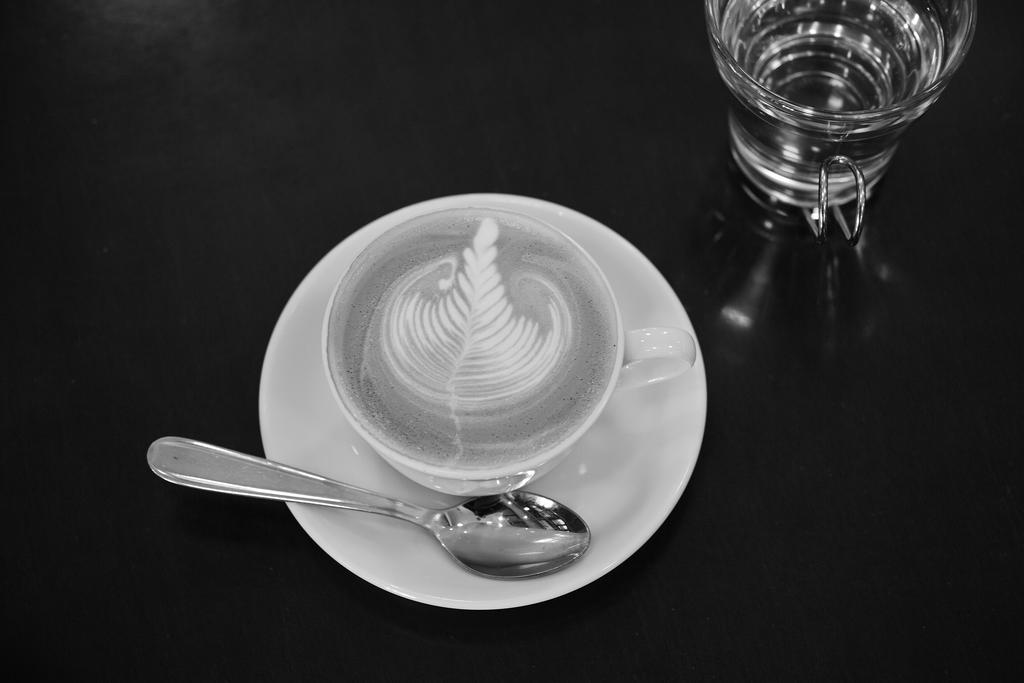What type of container is visible in the image? There is a glass and a cup in the image. What utensil is present in the image? There is a spoon in the image. What is the color of the saucer on which the objects are placed? The glass, cup, and spoon are on a white color saucer. What is the color of the surface on which the saucer is placed? The objects are on a black color surface. What type of punishment is being given to the tail in the image? There is no tail present in the image, so it is not possible to discuss any punishment related to it. 